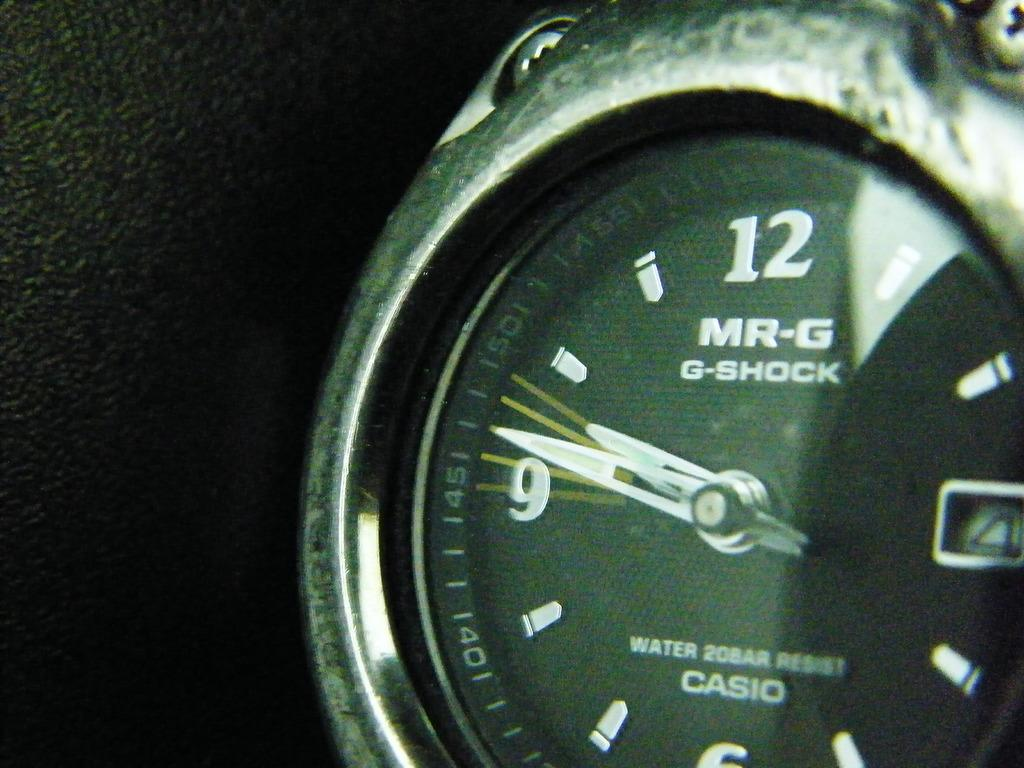<image>
Provide a brief description of the given image. A face of a MR-G G-Shock Water 20Bar Resist Casio watch with time of 9:47. 